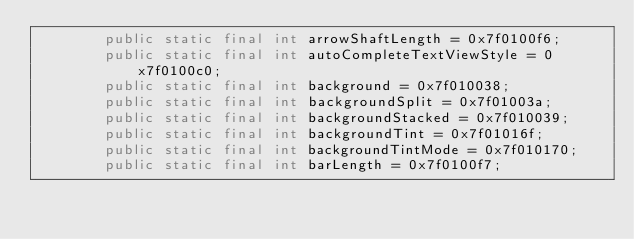<code> <loc_0><loc_0><loc_500><loc_500><_Java_>        public static final int arrowShaftLength = 0x7f0100f6;
        public static final int autoCompleteTextViewStyle = 0x7f0100c0;
        public static final int background = 0x7f010038;
        public static final int backgroundSplit = 0x7f01003a;
        public static final int backgroundStacked = 0x7f010039;
        public static final int backgroundTint = 0x7f01016f;
        public static final int backgroundTintMode = 0x7f010170;
        public static final int barLength = 0x7f0100f7;</code> 